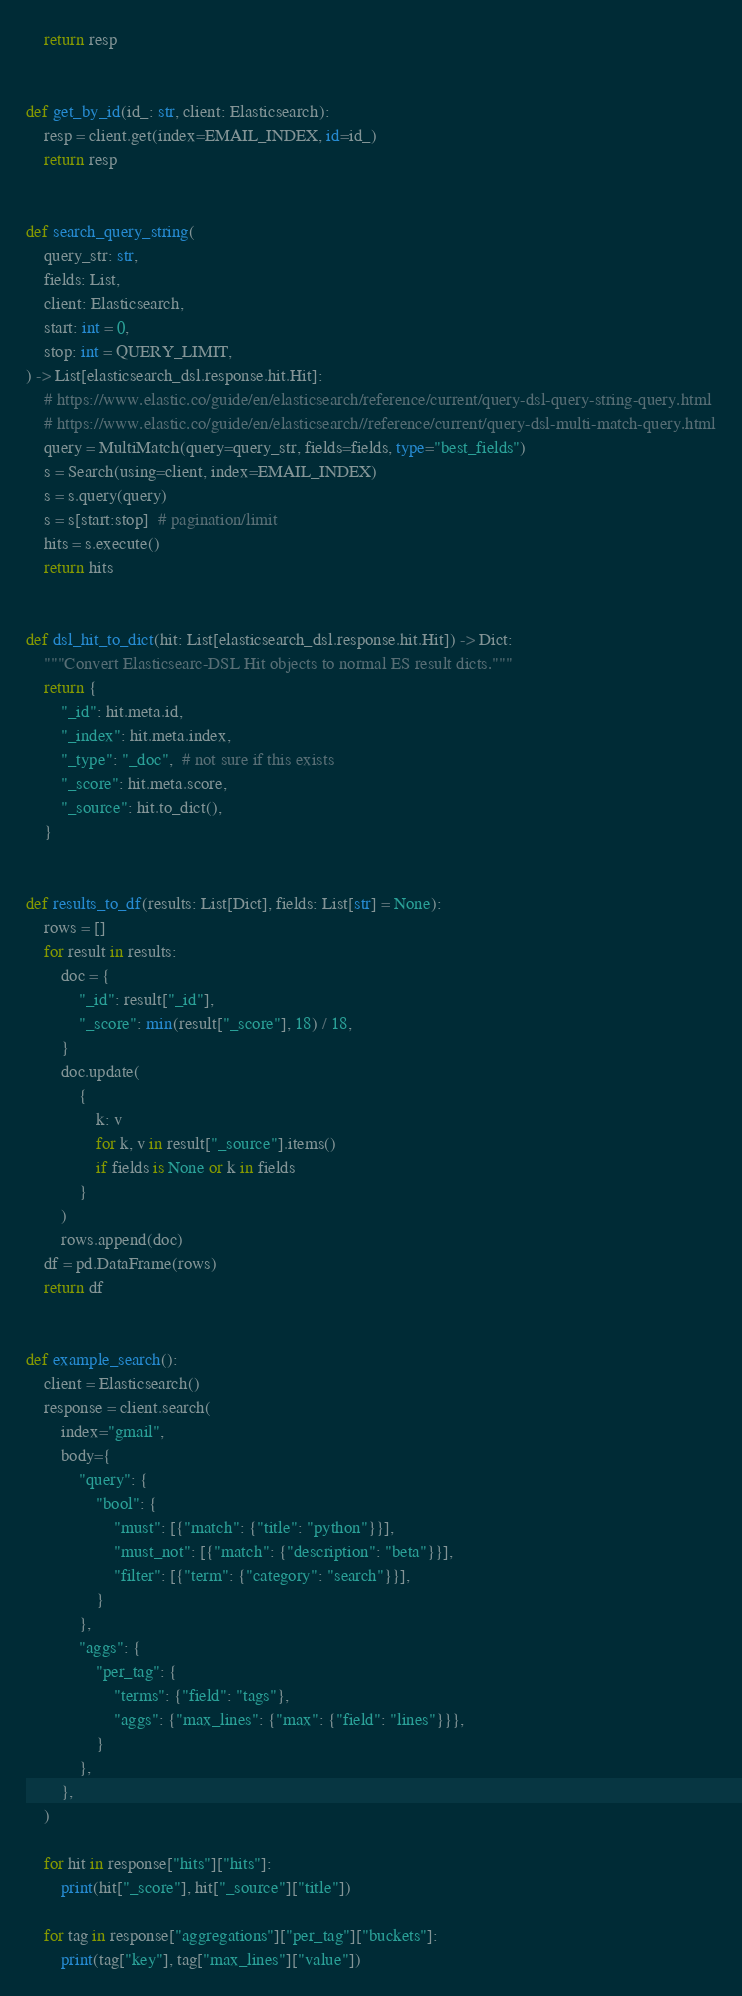Convert code to text. <code><loc_0><loc_0><loc_500><loc_500><_Python_>    return resp


def get_by_id(id_: str, client: Elasticsearch):
    resp = client.get(index=EMAIL_INDEX, id=id_)
    return resp


def search_query_string(
    query_str: str,
    fields: List,
    client: Elasticsearch,
    start: int = 0,
    stop: int = QUERY_LIMIT,
) -> List[elasticsearch_dsl.response.hit.Hit]:
    # https://www.elastic.co/guide/en/elasticsearch/reference/current/query-dsl-query-string-query.html
    # https://www.elastic.co/guide/en/elasticsearch//reference/current/query-dsl-multi-match-query.html
    query = MultiMatch(query=query_str, fields=fields, type="best_fields")
    s = Search(using=client, index=EMAIL_INDEX)
    s = s.query(query)
    s = s[start:stop]  # pagination/limit
    hits = s.execute()
    return hits


def dsl_hit_to_dict(hit: List[elasticsearch_dsl.response.hit.Hit]) -> Dict:
    """Convert Elasticsearc-DSL Hit objects to normal ES result dicts."""
    return {
        "_id": hit.meta.id,
        "_index": hit.meta.index,
        "_type": "_doc",  # not sure if this exists
        "_score": hit.meta.score,
        "_source": hit.to_dict(),
    }


def results_to_df(results: List[Dict], fields: List[str] = None):
    rows = []
    for result in results:
        doc = {
            "_id": result["_id"],
            "_score": min(result["_score"], 18) / 18,
        }
        doc.update(
            {
                k: v
                for k, v in result["_source"].items()
                if fields is None or k in fields
            }
        )
        rows.append(doc)
    df = pd.DataFrame(rows)
    return df


def example_search():
    client = Elasticsearch()
    response = client.search(
        index="gmail",
        body={
            "query": {
                "bool": {
                    "must": [{"match": {"title": "python"}}],
                    "must_not": [{"match": {"description": "beta"}}],
                    "filter": [{"term": {"category": "search"}}],
                }
            },
            "aggs": {
                "per_tag": {
                    "terms": {"field": "tags"},
                    "aggs": {"max_lines": {"max": {"field": "lines"}}},
                }
            },
        },
    )

    for hit in response["hits"]["hits"]:
        print(hit["_score"], hit["_source"]["title"])

    for tag in response["aggregations"]["per_tag"]["buckets"]:
        print(tag["key"], tag["max_lines"]["value"])
</code> 